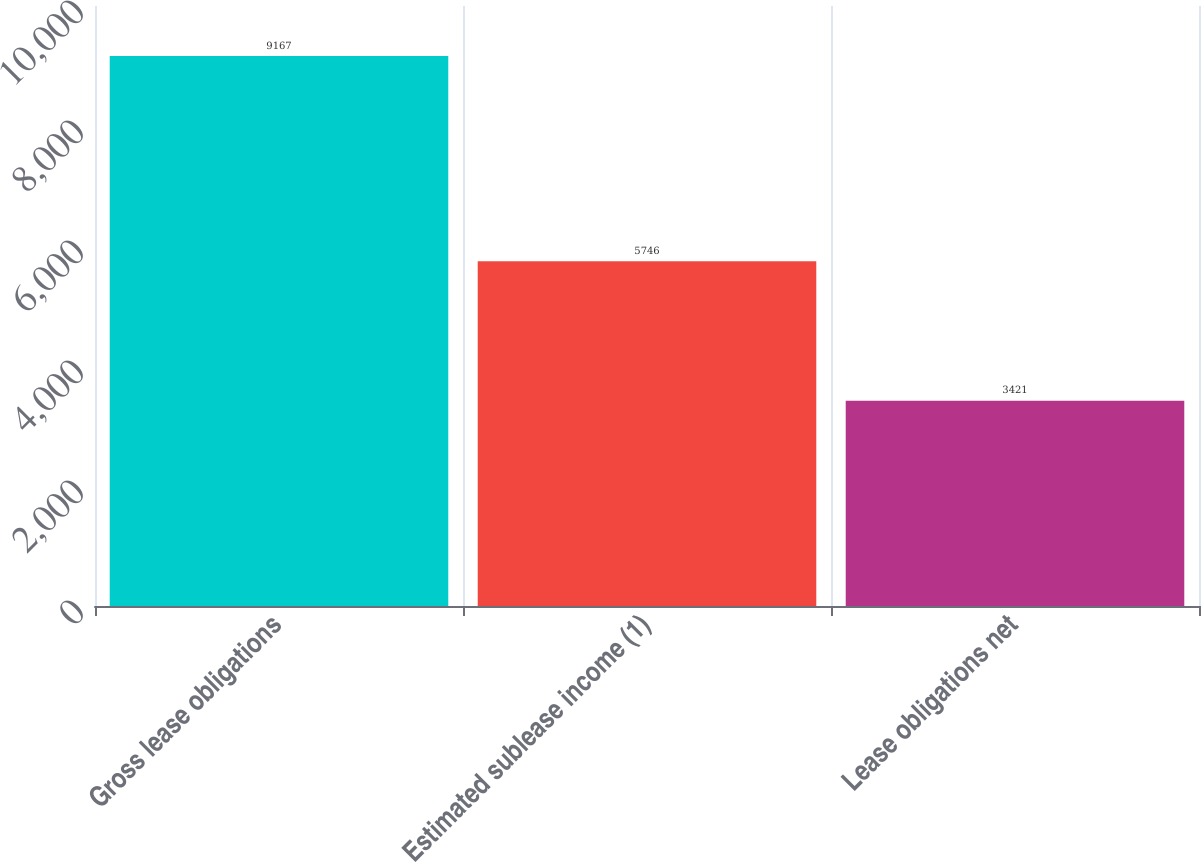<chart> <loc_0><loc_0><loc_500><loc_500><bar_chart><fcel>Gross lease obligations<fcel>Estimated sublease income (1)<fcel>Lease obligations net<nl><fcel>9167<fcel>5746<fcel>3421<nl></chart> 